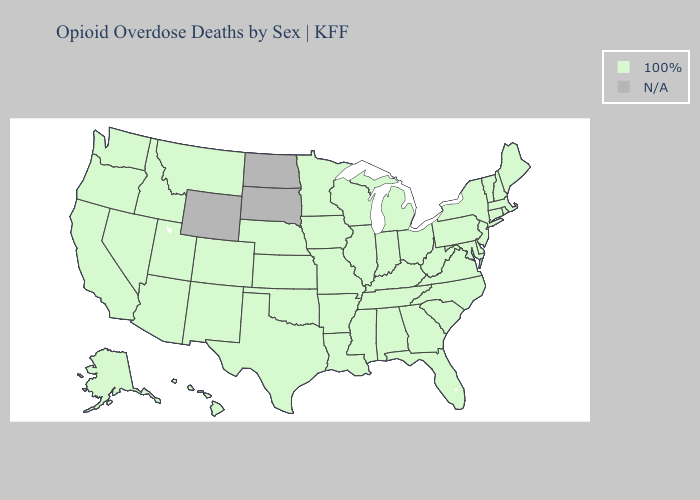Name the states that have a value in the range N/A?
Write a very short answer. North Dakota, South Dakota, Wyoming. What is the highest value in the Northeast ?
Concise answer only. 100%. What is the lowest value in states that border Washington?
Concise answer only. 100%. Among the states that border Nebraska , which have the highest value?
Give a very brief answer. Colorado, Iowa, Kansas, Missouri. Name the states that have a value in the range N/A?
Short answer required. North Dakota, South Dakota, Wyoming. Does the map have missing data?
Concise answer only. Yes. How many symbols are there in the legend?
Concise answer only. 2. Among the states that border New Mexico , which have the lowest value?
Concise answer only. Arizona, Colorado, Oklahoma, Texas, Utah. Which states have the lowest value in the USA?
Quick response, please. Alabama, Alaska, Arizona, Arkansas, California, Colorado, Connecticut, Delaware, Florida, Georgia, Hawaii, Idaho, Illinois, Indiana, Iowa, Kansas, Kentucky, Louisiana, Maine, Maryland, Massachusetts, Michigan, Minnesota, Mississippi, Missouri, Montana, Nebraska, Nevada, New Hampshire, New Jersey, New Mexico, New York, North Carolina, Ohio, Oklahoma, Oregon, Pennsylvania, Rhode Island, South Carolina, Tennessee, Texas, Utah, Vermont, Virginia, Washington, West Virginia, Wisconsin. Which states have the lowest value in the USA?
Write a very short answer. Alabama, Alaska, Arizona, Arkansas, California, Colorado, Connecticut, Delaware, Florida, Georgia, Hawaii, Idaho, Illinois, Indiana, Iowa, Kansas, Kentucky, Louisiana, Maine, Maryland, Massachusetts, Michigan, Minnesota, Mississippi, Missouri, Montana, Nebraska, Nevada, New Hampshire, New Jersey, New Mexico, New York, North Carolina, Ohio, Oklahoma, Oregon, Pennsylvania, Rhode Island, South Carolina, Tennessee, Texas, Utah, Vermont, Virginia, Washington, West Virginia, Wisconsin. Is the legend a continuous bar?
Write a very short answer. No. Does the map have missing data?
Write a very short answer. Yes. Which states hav the highest value in the South?
Concise answer only. Alabama, Arkansas, Delaware, Florida, Georgia, Kentucky, Louisiana, Maryland, Mississippi, North Carolina, Oklahoma, South Carolina, Tennessee, Texas, Virginia, West Virginia. Among the states that border Nevada , which have the lowest value?
Be succinct. Arizona, California, Idaho, Oregon, Utah. 